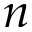Convert formula to latex. <formula><loc_0><loc_0><loc_500><loc_500>n</formula> 